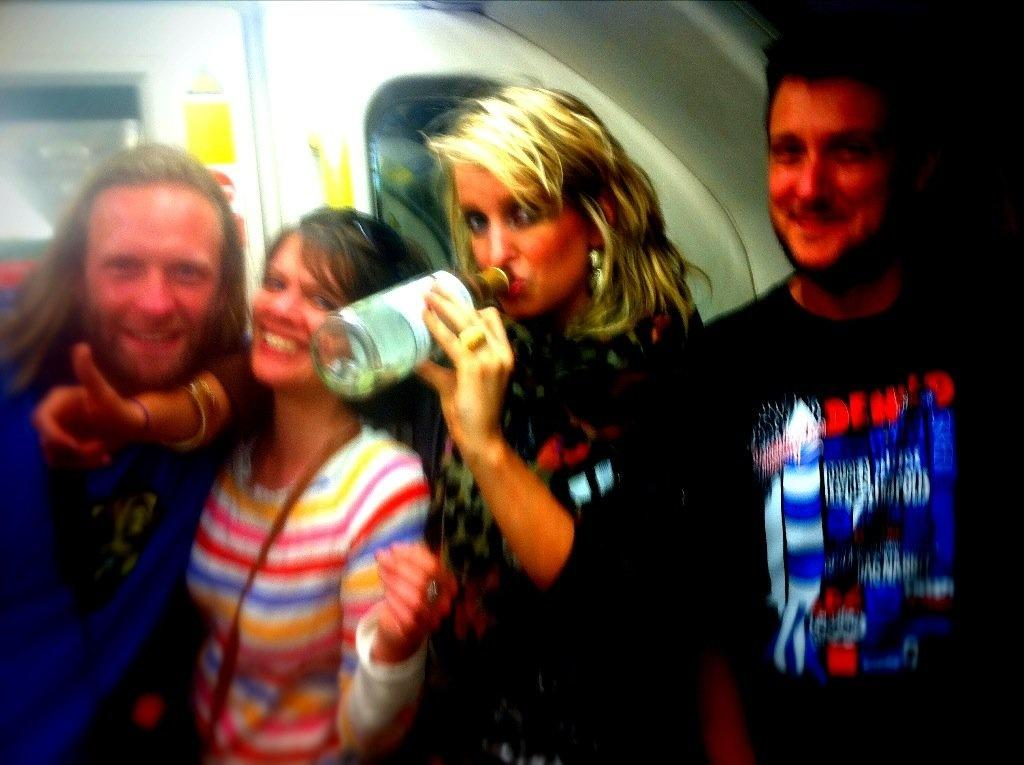How many people are present in the image? There are four people in the image, two ladies and two men. What are the ladies doing in the image? One of the ladies is drinking from a bottle. Can you describe the positioning of the men in the image? The men are on both sides of the image. What can be seen in the background of the image? There is a vehicle visible in the background of the image. What is the purpose of the baby in the image? There is no baby present in the image. 